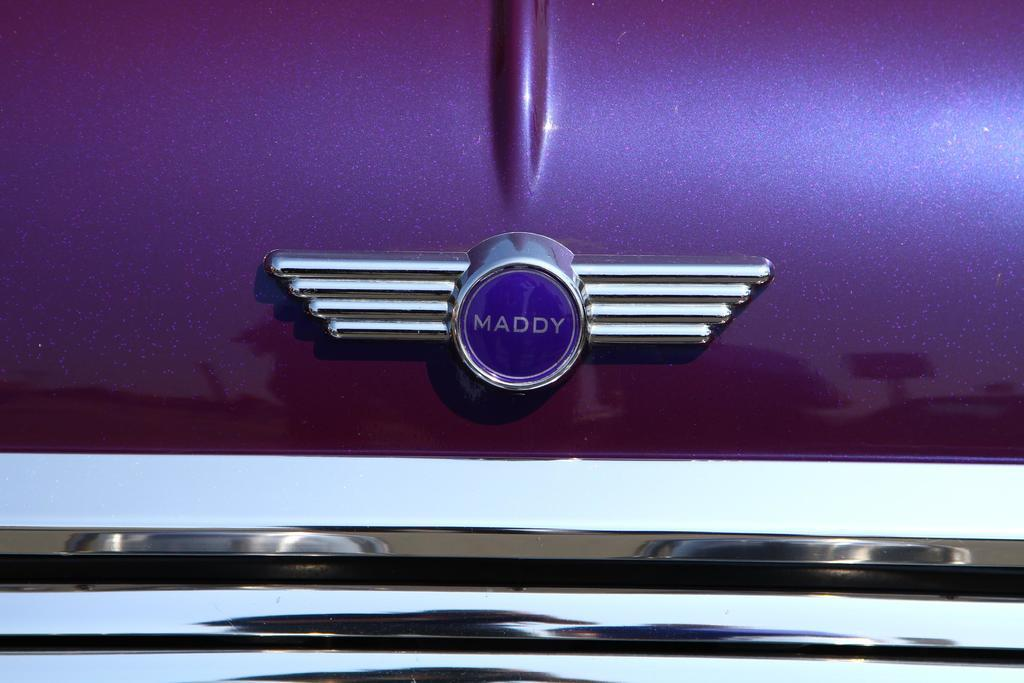What is the main subject of the image? The main subject of the image is a car. Can you describe any specific features of the car? Yes, the car has a logo on it. What type of nail is being hammered into the car's door in the image? There is no nail or hammer present in the image; it only features a car with a logo on it. 